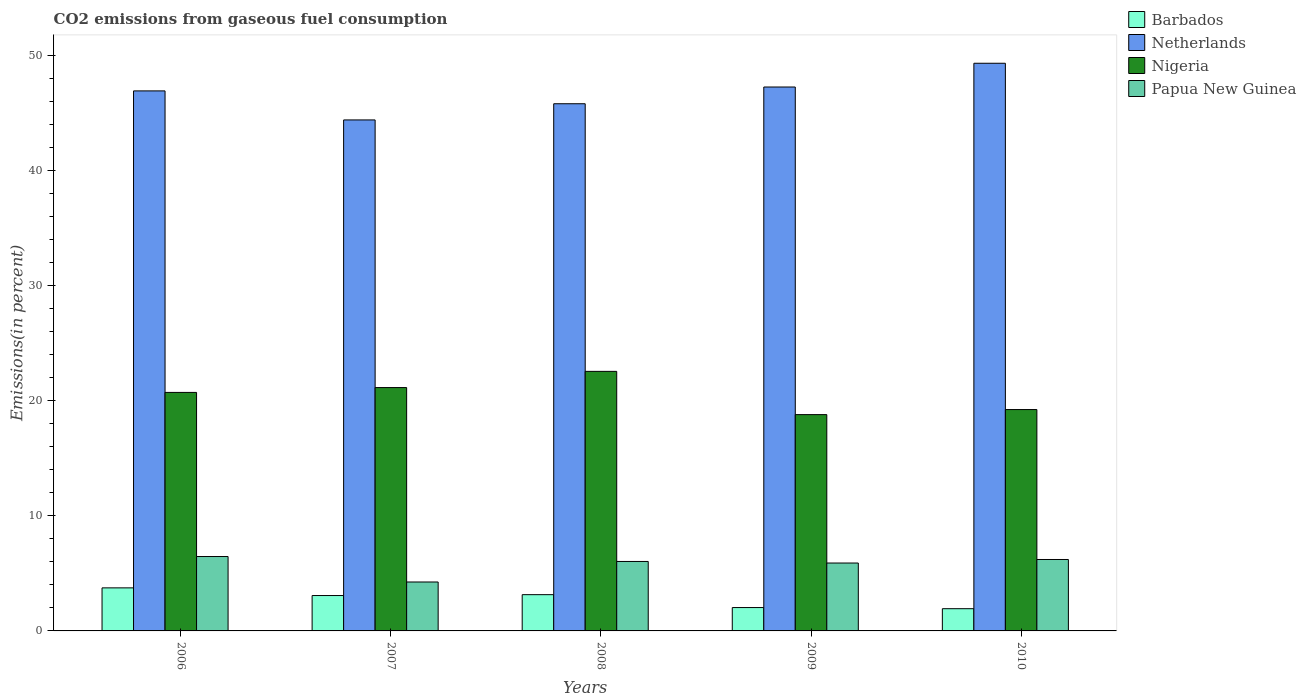How many different coloured bars are there?
Give a very brief answer. 4. How many bars are there on the 5th tick from the right?
Give a very brief answer. 4. What is the label of the 4th group of bars from the left?
Provide a succinct answer. 2009. What is the total CO2 emitted in Nigeria in 2008?
Give a very brief answer. 22.57. Across all years, what is the maximum total CO2 emitted in Papua New Guinea?
Your answer should be very brief. 6.47. Across all years, what is the minimum total CO2 emitted in Netherlands?
Provide a short and direct response. 44.43. What is the total total CO2 emitted in Nigeria in the graph?
Offer a very short reply. 102.52. What is the difference between the total CO2 emitted in Netherlands in 2006 and that in 2009?
Make the answer very short. -0.34. What is the difference between the total CO2 emitted in Papua New Guinea in 2007 and the total CO2 emitted in Barbados in 2010?
Give a very brief answer. 2.32. What is the average total CO2 emitted in Papua New Guinea per year?
Your answer should be very brief. 5.78. In the year 2008, what is the difference between the total CO2 emitted in Barbados and total CO2 emitted in Nigeria?
Give a very brief answer. -19.41. In how many years, is the total CO2 emitted in Papua New Guinea greater than 16 %?
Keep it short and to the point. 0. What is the ratio of the total CO2 emitted in Papua New Guinea in 2006 to that in 2008?
Provide a short and direct response. 1.07. Is the difference between the total CO2 emitted in Barbados in 2007 and 2010 greater than the difference between the total CO2 emitted in Nigeria in 2007 and 2010?
Your answer should be very brief. No. What is the difference between the highest and the second highest total CO2 emitted in Papua New Guinea?
Provide a short and direct response. 0.26. What is the difference between the highest and the lowest total CO2 emitted in Barbados?
Offer a very short reply. 1.81. In how many years, is the total CO2 emitted in Nigeria greater than the average total CO2 emitted in Nigeria taken over all years?
Keep it short and to the point. 3. Is it the case that in every year, the sum of the total CO2 emitted in Papua New Guinea and total CO2 emitted in Barbados is greater than the sum of total CO2 emitted in Nigeria and total CO2 emitted in Netherlands?
Make the answer very short. No. What does the 3rd bar from the left in 2008 represents?
Offer a very short reply. Nigeria. What does the 2nd bar from the right in 2009 represents?
Offer a terse response. Nigeria. How many bars are there?
Offer a very short reply. 20. What is the difference between two consecutive major ticks on the Y-axis?
Offer a very short reply. 10. Where does the legend appear in the graph?
Your response must be concise. Top right. How many legend labels are there?
Your response must be concise. 4. What is the title of the graph?
Give a very brief answer. CO2 emissions from gaseous fuel consumption. Does "Kosovo" appear as one of the legend labels in the graph?
Provide a short and direct response. No. What is the label or title of the Y-axis?
Your answer should be compact. Emissions(in percent). What is the Emissions(in percent) of Barbados in 2006?
Give a very brief answer. 3.74. What is the Emissions(in percent) of Netherlands in 2006?
Provide a succinct answer. 46.95. What is the Emissions(in percent) in Nigeria in 2006?
Provide a succinct answer. 20.74. What is the Emissions(in percent) of Papua New Guinea in 2006?
Provide a succinct answer. 6.47. What is the Emissions(in percent) in Barbados in 2007?
Provide a short and direct response. 3.08. What is the Emissions(in percent) of Netherlands in 2007?
Offer a terse response. 44.43. What is the Emissions(in percent) of Nigeria in 2007?
Your response must be concise. 21.16. What is the Emissions(in percent) in Papua New Guinea in 2007?
Keep it short and to the point. 4.25. What is the Emissions(in percent) of Barbados in 2008?
Give a very brief answer. 3.15. What is the Emissions(in percent) in Netherlands in 2008?
Offer a terse response. 45.84. What is the Emissions(in percent) of Nigeria in 2008?
Your answer should be very brief. 22.57. What is the Emissions(in percent) in Papua New Guinea in 2008?
Your answer should be compact. 6.04. What is the Emissions(in percent) of Barbados in 2009?
Make the answer very short. 2.03. What is the Emissions(in percent) of Netherlands in 2009?
Make the answer very short. 47.29. What is the Emissions(in percent) of Nigeria in 2009?
Provide a succinct answer. 18.81. What is the Emissions(in percent) of Papua New Guinea in 2009?
Give a very brief answer. 5.9. What is the Emissions(in percent) of Barbados in 2010?
Ensure brevity in your answer.  1.93. What is the Emissions(in percent) of Netherlands in 2010?
Your answer should be compact. 49.36. What is the Emissions(in percent) of Nigeria in 2010?
Keep it short and to the point. 19.25. What is the Emissions(in percent) of Papua New Guinea in 2010?
Provide a short and direct response. 6.21. Across all years, what is the maximum Emissions(in percent) in Barbados?
Provide a short and direct response. 3.74. Across all years, what is the maximum Emissions(in percent) in Netherlands?
Provide a succinct answer. 49.36. Across all years, what is the maximum Emissions(in percent) in Nigeria?
Offer a terse response. 22.57. Across all years, what is the maximum Emissions(in percent) in Papua New Guinea?
Your answer should be compact. 6.47. Across all years, what is the minimum Emissions(in percent) in Barbados?
Ensure brevity in your answer.  1.93. Across all years, what is the minimum Emissions(in percent) in Netherlands?
Offer a very short reply. 44.43. Across all years, what is the minimum Emissions(in percent) of Nigeria?
Offer a terse response. 18.81. Across all years, what is the minimum Emissions(in percent) of Papua New Guinea?
Provide a succinct answer. 4.25. What is the total Emissions(in percent) in Barbados in the graph?
Keep it short and to the point. 13.94. What is the total Emissions(in percent) in Netherlands in the graph?
Your answer should be very brief. 233.87. What is the total Emissions(in percent) in Nigeria in the graph?
Ensure brevity in your answer.  102.52. What is the total Emissions(in percent) in Papua New Guinea in the graph?
Give a very brief answer. 28.88. What is the difference between the Emissions(in percent) in Barbados in 2006 and that in 2007?
Ensure brevity in your answer.  0.67. What is the difference between the Emissions(in percent) in Netherlands in 2006 and that in 2007?
Provide a short and direct response. 2.52. What is the difference between the Emissions(in percent) of Nigeria in 2006 and that in 2007?
Offer a very short reply. -0.42. What is the difference between the Emissions(in percent) in Papua New Guinea in 2006 and that in 2007?
Ensure brevity in your answer.  2.21. What is the difference between the Emissions(in percent) of Barbados in 2006 and that in 2008?
Offer a very short reply. 0.59. What is the difference between the Emissions(in percent) in Netherlands in 2006 and that in 2008?
Keep it short and to the point. 1.12. What is the difference between the Emissions(in percent) in Nigeria in 2006 and that in 2008?
Offer a very short reply. -1.83. What is the difference between the Emissions(in percent) in Papua New Guinea in 2006 and that in 2008?
Ensure brevity in your answer.  0.43. What is the difference between the Emissions(in percent) in Barbados in 2006 and that in 2009?
Give a very brief answer. 1.71. What is the difference between the Emissions(in percent) of Netherlands in 2006 and that in 2009?
Offer a terse response. -0.34. What is the difference between the Emissions(in percent) of Nigeria in 2006 and that in 2009?
Keep it short and to the point. 1.93. What is the difference between the Emissions(in percent) in Papua New Guinea in 2006 and that in 2009?
Provide a succinct answer. 0.56. What is the difference between the Emissions(in percent) in Barbados in 2006 and that in 2010?
Give a very brief answer. 1.81. What is the difference between the Emissions(in percent) in Netherlands in 2006 and that in 2010?
Offer a very short reply. -2.4. What is the difference between the Emissions(in percent) in Nigeria in 2006 and that in 2010?
Provide a succinct answer. 1.49. What is the difference between the Emissions(in percent) in Papua New Guinea in 2006 and that in 2010?
Your answer should be compact. 0.26. What is the difference between the Emissions(in percent) in Barbados in 2007 and that in 2008?
Give a very brief answer. -0.08. What is the difference between the Emissions(in percent) in Netherlands in 2007 and that in 2008?
Ensure brevity in your answer.  -1.41. What is the difference between the Emissions(in percent) of Nigeria in 2007 and that in 2008?
Offer a terse response. -1.41. What is the difference between the Emissions(in percent) of Papua New Guinea in 2007 and that in 2008?
Keep it short and to the point. -1.79. What is the difference between the Emissions(in percent) in Barbados in 2007 and that in 2009?
Make the answer very short. 1.05. What is the difference between the Emissions(in percent) in Netherlands in 2007 and that in 2009?
Offer a very short reply. -2.86. What is the difference between the Emissions(in percent) in Nigeria in 2007 and that in 2009?
Your answer should be very brief. 2.35. What is the difference between the Emissions(in percent) of Papua New Guinea in 2007 and that in 2009?
Provide a short and direct response. -1.65. What is the difference between the Emissions(in percent) of Barbados in 2007 and that in 2010?
Offer a terse response. 1.14. What is the difference between the Emissions(in percent) in Netherlands in 2007 and that in 2010?
Offer a terse response. -4.93. What is the difference between the Emissions(in percent) of Nigeria in 2007 and that in 2010?
Your answer should be very brief. 1.91. What is the difference between the Emissions(in percent) of Papua New Guinea in 2007 and that in 2010?
Your response must be concise. -1.96. What is the difference between the Emissions(in percent) in Barbados in 2008 and that in 2009?
Your answer should be very brief. 1.12. What is the difference between the Emissions(in percent) of Netherlands in 2008 and that in 2009?
Keep it short and to the point. -1.45. What is the difference between the Emissions(in percent) in Nigeria in 2008 and that in 2009?
Your answer should be compact. 3.76. What is the difference between the Emissions(in percent) of Papua New Guinea in 2008 and that in 2009?
Ensure brevity in your answer.  0.14. What is the difference between the Emissions(in percent) in Barbados in 2008 and that in 2010?
Your answer should be very brief. 1.22. What is the difference between the Emissions(in percent) in Netherlands in 2008 and that in 2010?
Your answer should be compact. -3.52. What is the difference between the Emissions(in percent) of Nigeria in 2008 and that in 2010?
Give a very brief answer. 3.32. What is the difference between the Emissions(in percent) of Papua New Guinea in 2008 and that in 2010?
Give a very brief answer. -0.17. What is the difference between the Emissions(in percent) of Barbados in 2009 and that in 2010?
Your answer should be compact. 0.1. What is the difference between the Emissions(in percent) of Netherlands in 2009 and that in 2010?
Provide a short and direct response. -2.07. What is the difference between the Emissions(in percent) in Nigeria in 2009 and that in 2010?
Your answer should be compact. -0.44. What is the difference between the Emissions(in percent) in Papua New Guinea in 2009 and that in 2010?
Provide a short and direct response. -0.31. What is the difference between the Emissions(in percent) in Barbados in 2006 and the Emissions(in percent) in Netherlands in 2007?
Offer a very short reply. -40.69. What is the difference between the Emissions(in percent) in Barbados in 2006 and the Emissions(in percent) in Nigeria in 2007?
Your response must be concise. -17.42. What is the difference between the Emissions(in percent) in Barbados in 2006 and the Emissions(in percent) in Papua New Guinea in 2007?
Ensure brevity in your answer.  -0.51. What is the difference between the Emissions(in percent) of Netherlands in 2006 and the Emissions(in percent) of Nigeria in 2007?
Offer a very short reply. 25.79. What is the difference between the Emissions(in percent) in Netherlands in 2006 and the Emissions(in percent) in Papua New Guinea in 2007?
Your answer should be compact. 42.7. What is the difference between the Emissions(in percent) in Nigeria in 2006 and the Emissions(in percent) in Papua New Guinea in 2007?
Your answer should be compact. 16.48. What is the difference between the Emissions(in percent) of Barbados in 2006 and the Emissions(in percent) of Netherlands in 2008?
Give a very brief answer. -42.09. What is the difference between the Emissions(in percent) in Barbados in 2006 and the Emissions(in percent) in Nigeria in 2008?
Offer a terse response. -18.82. What is the difference between the Emissions(in percent) in Barbados in 2006 and the Emissions(in percent) in Papua New Guinea in 2008?
Provide a short and direct response. -2.3. What is the difference between the Emissions(in percent) in Netherlands in 2006 and the Emissions(in percent) in Nigeria in 2008?
Your answer should be very brief. 24.39. What is the difference between the Emissions(in percent) of Netherlands in 2006 and the Emissions(in percent) of Papua New Guinea in 2008?
Your answer should be very brief. 40.91. What is the difference between the Emissions(in percent) in Nigeria in 2006 and the Emissions(in percent) in Papua New Guinea in 2008?
Keep it short and to the point. 14.7. What is the difference between the Emissions(in percent) of Barbados in 2006 and the Emissions(in percent) of Netherlands in 2009?
Keep it short and to the point. -43.55. What is the difference between the Emissions(in percent) in Barbados in 2006 and the Emissions(in percent) in Nigeria in 2009?
Keep it short and to the point. -15.06. What is the difference between the Emissions(in percent) in Barbados in 2006 and the Emissions(in percent) in Papua New Guinea in 2009?
Provide a short and direct response. -2.16. What is the difference between the Emissions(in percent) in Netherlands in 2006 and the Emissions(in percent) in Nigeria in 2009?
Make the answer very short. 28.15. What is the difference between the Emissions(in percent) in Netherlands in 2006 and the Emissions(in percent) in Papua New Guinea in 2009?
Offer a terse response. 41.05. What is the difference between the Emissions(in percent) of Nigeria in 2006 and the Emissions(in percent) of Papua New Guinea in 2009?
Your response must be concise. 14.83. What is the difference between the Emissions(in percent) in Barbados in 2006 and the Emissions(in percent) in Netherlands in 2010?
Make the answer very short. -45.61. What is the difference between the Emissions(in percent) of Barbados in 2006 and the Emissions(in percent) of Nigeria in 2010?
Keep it short and to the point. -15.5. What is the difference between the Emissions(in percent) in Barbados in 2006 and the Emissions(in percent) in Papua New Guinea in 2010?
Ensure brevity in your answer.  -2.47. What is the difference between the Emissions(in percent) of Netherlands in 2006 and the Emissions(in percent) of Nigeria in 2010?
Keep it short and to the point. 27.71. What is the difference between the Emissions(in percent) in Netherlands in 2006 and the Emissions(in percent) in Papua New Guinea in 2010?
Make the answer very short. 40.74. What is the difference between the Emissions(in percent) in Nigeria in 2006 and the Emissions(in percent) in Papua New Guinea in 2010?
Give a very brief answer. 14.53. What is the difference between the Emissions(in percent) of Barbados in 2007 and the Emissions(in percent) of Netherlands in 2008?
Ensure brevity in your answer.  -42.76. What is the difference between the Emissions(in percent) of Barbados in 2007 and the Emissions(in percent) of Nigeria in 2008?
Ensure brevity in your answer.  -19.49. What is the difference between the Emissions(in percent) in Barbados in 2007 and the Emissions(in percent) in Papua New Guinea in 2008?
Ensure brevity in your answer.  -2.96. What is the difference between the Emissions(in percent) in Netherlands in 2007 and the Emissions(in percent) in Nigeria in 2008?
Your response must be concise. 21.86. What is the difference between the Emissions(in percent) of Netherlands in 2007 and the Emissions(in percent) of Papua New Guinea in 2008?
Your answer should be very brief. 38.39. What is the difference between the Emissions(in percent) in Nigeria in 2007 and the Emissions(in percent) in Papua New Guinea in 2008?
Ensure brevity in your answer.  15.12. What is the difference between the Emissions(in percent) in Barbados in 2007 and the Emissions(in percent) in Netherlands in 2009?
Offer a very short reply. -44.21. What is the difference between the Emissions(in percent) of Barbados in 2007 and the Emissions(in percent) of Nigeria in 2009?
Provide a succinct answer. -15.73. What is the difference between the Emissions(in percent) of Barbados in 2007 and the Emissions(in percent) of Papua New Guinea in 2009?
Offer a very short reply. -2.83. What is the difference between the Emissions(in percent) in Netherlands in 2007 and the Emissions(in percent) in Nigeria in 2009?
Your response must be concise. 25.62. What is the difference between the Emissions(in percent) of Netherlands in 2007 and the Emissions(in percent) of Papua New Guinea in 2009?
Ensure brevity in your answer.  38.53. What is the difference between the Emissions(in percent) of Nigeria in 2007 and the Emissions(in percent) of Papua New Guinea in 2009?
Your answer should be very brief. 15.26. What is the difference between the Emissions(in percent) of Barbados in 2007 and the Emissions(in percent) of Netherlands in 2010?
Keep it short and to the point. -46.28. What is the difference between the Emissions(in percent) of Barbados in 2007 and the Emissions(in percent) of Nigeria in 2010?
Provide a succinct answer. -16.17. What is the difference between the Emissions(in percent) of Barbados in 2007 and the Emissions(in percent) of Papua New Guinea in 2010?
Offer a very short reply. -3.13. What is the difference between the Emissions(in percent) of Netherlands in 2007 and the Emissions(in percent) of Nigeria in 2010?
Offer a very short reply. 25.18. What is the difference between the Emissions(in percent) of Netherlands in 2007 and the Emissions(in percent) of Papua New Guinea in 2010?
Make the answer very short. 38.22. What is the difference between the Emissions(in percent) of Nigeria in 2007 and the Emissions(in percent) of Papua New Guinea in 2010?
Give a very brief answer. 14.95. What is the difference between the Emissions(in percent) in Barbados in 2008 and the Emissions(in percent) in Netherlands in 2009?
Ensure brevity in your answer.  -44.14. What is the difference between the Emissions(in percent) in Barbados in 2008 and the Emissions(in percent) in Nigeria in 2009?
Offer a very short reply. -15.65. What is the difference between the Emissions(in percent) of Barbados in 2008 and the Emissions(in percent) of Papua New Guinea in 2009?
Your answer should be very brief. -2.75. What is the difference between the Emissions(in percent) in Netherlands in 2008 and the Emissions(in percent) in Nigeria in 2009?
Make the answer very short. 27.03. What is the difference between the Emissions(in percent) in Netherlands in 2008 and the Emissions(in percent) in Papua New Guinea in 2009?
Your response must be concise. 39.93. What is the difference between the Emissions(in percent) of Nigeria in 2008 and the Emissions(in percent) of Papua New Guinea in 2009?
Provide a short and direct response. 16.66. What is the difference between the Emissions(in percent) of Barbados in 2008 and the Emissions(in percent) of Netherlands in 2010?
Your response must be concise. -46.2. What is the difference between the Emissions(in percent) in Barbados in 2008 and the Emissions(in percent) in Nigeria in 2010?
Ensure brevity in your answer.  -16.09. What is the difference between the Emissions(in percent) in Barbados in 2008 and the Emissions(in percent) in Papua New Guinea in 2010?
Give a very brief answer. -3.06. What is the difference between the Emissions(in percent) of Netherlands in 2008 and the Emissions(in percent) of Nigeria in 2010?
Your answer should be very brief. 26.59. What is the difference between the Emissions(in percent) in Netherlands in 2008 and the Emissions(in percent) in Papua New Guinea in 2010?
Your answer should be compact. 39.63. What is the difference between the Emissions(in percent) of Nigeria in 2008 and the Emissions(in percent) of Papua New Guinea in 2010?
Give a very brief answer. 16.36. What is the difference between the Emissions(in percent) of Barbados in 2009 and the Emissions(in percent) of Netherlands in 2010?
Provide a short and direct response. -47.33. What is the difference between the Emissions(in percent) of Barbados in 2009 and the Emissions(in percent) of Nigeria in 2010?
Provide a short and direct response. -17.22. What is the difference between the Emissions(in percent) of Barbados in 2009 and the Emissions(in percent) of Papua New Guinea in 2010?
Make the answer very short. -4.18. What is the difference between the Emissions(in percent) in Netherlands in 2009 and the Emissions(in percent) in Nigeria in 2010?
Make the answer very short. 28.04. What is the difference between the Emissions(in percent) of Netherlands in 2009 and the Emissions(in percent) of Papua New Guinea in 2010?
Provide a short and direct response. 41.08. What is the difference between the Emissions(in percent) of Nigeria in 2009 and the Emissions(in percent) of Papua New Guinea in 2010?
Make the answer very short. 12.6. What is the average Emissions(in percent) in Barbados per year?
Your answer should be very brief. 2.79. What is the average Emissions(in percent) in Netherlands per year?
Your answer should be very brief. 46.77. What is the average Emissions(in percent) of Nigeria per year?
Give a very brief answer. 20.5. What is the average Emissions(in percent) in Papua New Guinea per year?
Provide a succinct answer. 5.78. In the year 2006, what is the difference between the Emissions(in percent) of Barbados and Emissions(in percent) of Netherlands?
Keep it short and to the point. -43.21. In the year 2006, what is the difference between the Emissions(in percent) in Barbados and Emissions(in percent) in Nigeria?
Ensure brevity in your answer.  -16.99. In the year 2006, what is the difference between the Emissions(in percent) in Barbados and Emissions(in percent) in Papua New Guinea?
Your answer should be compact. -2.72. In the year 2006, what is the difference between the Emissions(in percent) in Netherlands and Emissions(in percent) in Nigeria?
Make the answer very short. 26.22. In the year 2006, what is the difference between the Emissions(in percent) of Netherlands and Emissions(in percent) of Papua New Guinea?
Provide a short and direct response. 40.48. In the year 2006, what is the difference between the Emissions(in percent) in Nigeria and Emissions(in percent) in Papua New Guinea?
Provide a short and direct response. 14.27. In the year 2007, what is the difference between the Emissions(in percent) of Barbados and Emissions(in percent) of Netherlands?
Offer a very short reply. -41.35. In the year 2007, what is the difference between the Emissions(in percent) of Barbados and Emissions(in percent) of Nigeria?
Your answer should be compact. -18.08. In the year 2007, what is the difference between the Emissions(in percent) in Barbados and Emissions(in percent) in Papua New Guinea?
Offer a terse response. -1.18. In the year 2007, what is the difference between the Emissions(in percent) in Netherlands and Emissions(in percent) in Nigeria?
Your answer should be very brief. 23.27. In the year 2007, what is the difference between the Emissions(in percent) of Netherlands and Emissions(in percent) of Papua New Guinea?
Keep it short and to the point. 40.18. In the year 2007, what is the difference between the Emissions(in percent) in Nigeria and Emissions(in percent) in Papua New Guinea?
Offer a terse response. 16.9. In the year 2008, what is the difference between the Emissions(in percent) of Barbados and Emissions(in percent) of Netherlands?
Ensure brevity in your answer.  -42.68. In the year 2008, what is the difference between the Emissions(in percent) of Barbados and Emissions(in percent) of Nigeria?
Offer a terse response. -19.41. In the year 2008, what is the difference between the Emissions(in percent) in Barbados and Emissions(in percent) in Papua New Guinea?
Your response must be concise. -2.89. In the year 2008, what is the difference between the Emissions(in percent) of Netherlands and Emissions(in percent) of Nigeria?
Keep it short and to the point. 23.27. In the year 2008, what is the difference between the Emissions(in percent) in Netherlands and Emissions(in percent) in Papua New Guinea?
Offer a very short reply. 39.8. In the year 2008, what is the difference between the Emissions(in percent) in Nigeria and Emissions(in percent) in Papua New Guinea?
Ensure brevity in your answer.  16.53. In the year 2009, what is the difference between the Emissions(in percent) of Barbados and Emissions(in percent) of Netherlands?
Your response must be concise. -45.26. In the year 2009, what is the difference between the Emissions(in percent) of Barbados and Emissions(in percent) of Nigeria?
Keep it short and to the point. -16.78. In the year 2009, what is the difference between the Emissions(in percent) of Barbados and Emissions(in percent) of Papua New Guinea?
Give a very brief answer. -3.87. In the year 2009, what is the difference between the Emissions(in percent) in Netherlands and Emissions(in percent) in Nigeria?
Provide a succinct answer. 28.48. In the year 2009, what is the difference between the Emissions(in percent) in Netherlands and Emissions(in percent) in Papua New Guinea?
Your response must be concise. 41.39. In the year 2009, what is the difference between the Emissions(in percent) of Nigeria and Emissions(in percent) of Papua New Guinea?
Provide a short and direct response. 12.9. In the year 2010, what is the difference between the Emissions(in percent) in Barbados and Emissions(in percent) in Netherlands?
Keep it short and to the point. -47.42. In the year 2010, what is the difference between the Emissions(in percent) in Barbados and Emissions(in percent) in Nigeria?
Your response must be concise. -17.31. In the year 2010, what is the difference between the Emissions(in percent) in Barbados and Emissions(in percent) in Papua New Guinea?
Provide a short and direct response. -4.28. In the year 2010, what is the difference between the Emissions(in percent) in Netherlands and Emissions(in percent) in Nigeria?
Provide a succinct answer. 30.11. In the year 2010, what is the difference between the Emissions(in percent) in Netherlands and Emissions(in percent) in Papua New Guinea?
Your response must be concise. 43.15. In the year 2010, what is the difference between the Emissions(in percent) in Nigeria and Emissions(in percent) in Papua New Guinea?
Provide a succinct answer. 13.04. What is the ratio of the Emissions(in percent) of Barbados in 2006 to that in 2007?
Ensure brevity in your answer.  1.22. What is the ratio of the Emissions(in percent) of Netherlands in 2006 to that in 2007?
Your response must be concise. 1.06. What is the ratio of the Emissions(in percent) in Nigeria in 2006 to that in 2007?
Give a very brief answer. 0.98. What is the ratio of the Emissions(in percent) of Papua New Guinea in 2006 to that in 2007?
Provide a succinct answer. 1.52. What is the ratio of the Emissions(in percent) of Barbados in 2006 to that in 2008?
Ensure brevity in your answer.  1.19. What is the ratio of the Emissions(in percent) in Netherlands in 2006 to that in 2008?
Make the answer very short. 1.02. What is the ratio of the Emissions(in percent) of Nigeria in 2006 to that in 2008?
Provide a short and direct response. 0.92. What is the ratio of the Emissions(in percent) of Papua New Guinea in 2006 to that in 2008?
Your response must be concise. 1.07. What is the ratio of the Emissions(in percent) of Barbados in 2006 to that in 2009?
Provide a succinct answer. 1.84. What is the ratio of the Emissions(in percent) in Netherlands in 2006 to that in 2009?
Your answer should be compact. 0.99. What is the ratio of the Emissions(in percent) of Nigeria in 2006 to that in 2009?
Your answer should be very brief. 1.1. What is the ratio of the Emissions(in percent) of Papua New Guinea in 2006 to that in 2009?
Your response must be concise. 1.1. What is the ratio of the Emissions(in percent) in Barbados in 2006 to that in 2010?
Offer a very short reply. 1.94. What is the ratio of the Emissions(in percent) in Netherlands in 2006 to that in 2010?
Ensure brevity in your answer.  0.95. What is the ratio of the Emissions(in percent) in Nigeria in 2006 to that in 2010?
Ensure brevity in your answer.  1.08. What is the ratio of the Emissions(in percent) in Papua New Guinea in 2006 to that in 2010?
Make the answer very short. 1.04. What is the ratio of the Emissions(in percent) in Barbados in 2007 to that in 2008?
Give a very brief answer. 0.98. What is the ratio of the Emissions(in percent) of Netherlands in 2007 to that in 2008?
Your answer should be very brief. 0.97. What is the ratio of the Emissions(in percent) in Nigeria in 2007 to that in 2008?
Your answer should be very brief. 0.94. What is the ratio of the Emissions(in percent) in Papua New Guinea in 2007 to that in 2008?
Keep it short and to the point. 0.7. What is the ratio of the Emissions(in percent) of Barbados in 2007 to that in 2009?
Offer a very short reply. 1.51. What is the ratio of the Emissions(in percent) of Netherlands in 2007 to that in 2009?
Provide a short and direct response. 0.94. What is the ratio of the Emissions(in percent) in Papua New Guinea in 2007 to that in 2009?
Your answer should be compact. 0.72. What is the ratio of the Emissions(in percent) in Barbados in 2007 to that in 2010?
Offer a terse response. 1.59. What is the ratio of the Emissions(in percent) of Netherlands in 2007 to that in 2010?
Your response must be concise. 0.9. What is the ratio of the Emissions(in percent) in Nigeria in 2007 to that in 2010?
Offer a terse response. 1.1. What is the ratio of the Emissions(in percent) in Papua New Guinea in 2007 to that in 2010?
Provide a short and direct response. 0.69. What is the ratio of the Emissions(in percent) in Barbados in 2008 to that in 2009?
Ensure brevity in your answer.  1.55. What is the ratio of the Emissions(in percent) in Netherlands in 2008 to that in 2009?
Your answer should be very brief. 0.97. What is the ratio of the Emissions(in percent) in Nigeria in 2008 to that in 2009?
Give a very brief answer. 1.2. What is the ratio of the Emissions(in percent) of Papua New Guinea in 2008 to that in 2009?
Your answer should be very brief. 1.02. What is the ratio of the Emissions(in percent) of Barbados in 2008 to that in 2010?
Make the answer very short. 1.63. What is the ratio of the Emissions(in percent) in Netherlands in 2008 to that in 2010?
Your answer should be very brief. 0.93. What is the ratio of the Emissions(in percent) of Nigeria in 2008 to that in 2010?
Give a very brief answer. 1.17. What is the ratio of the Emissions(in percent) in Papua New Guinea in 2008 to that in 2010?
Give a very brief answer. 0.97. What is the ratio of the Emissions(in percent) of Barbados in 2009 to that in 2010?
Provide a short and direct response. 1.05. What is the ratio of the Emissions(in percent) in Netherlands in 2009 to that in 2010?
Give a very brief answer. 0.96. What is the ratio of the Emissions(in percent) of Nigeria in 2009 to that in 2010?
Ensure brevity in your answer.  0.98. What is the ratio of the Emissions(in percent) in Papua New Guinea in 2009 to that in 2010?
Your response must be concise. 0.95. What is the difference between the highest and the second highest Emissions(in percent) of Barbados?
Provide a short and direct response. 0.59. What is the difference between the highest and the second highest Emissions(in percent) in Netherlands?
Make the answer very short. 2.07. What is the difference between the highest and the second highest Emissions(in percent) of Nigeria?
Offer a terse response. 1.41. What is the difference between the highest and the second highest Emissions(in percent) in Papua New Guinea?
Your answer should be compact. 0.26. What is the difference between the highest and the lowest Emissions(in percent) in Barbados?
Provide a short and direct response. 1.81. What is the difference between the highest and the lowest Emissions(in percent) in Netherlands?
Give a very brief answer. 4.93. What is the difference between the highest and the lowest Emissions(in percent) in Nigeria?
Make the answer very short. 3.76. What is the difference between the highest and the lowest Emissions(in percent) in Papua New Guinea?
Your response must be concise. 2.21. 